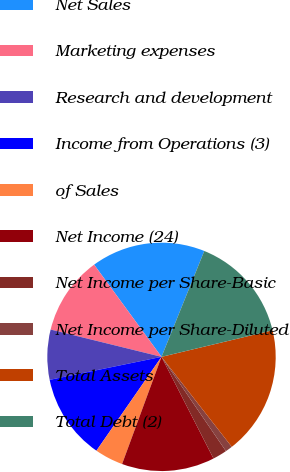Convert chart. <chart><loc_0><loc_0><loc_500><loc_500><pie_chart><fcel>Net Sales<fcel>Marketing expenses<fcel>Research and development<fcel>Income from Operations (3)<fcel>of Sales<fcel>Net Income (24)<fcel>Net Income per Share-Basic<fcel>Net Income per Share-Diluted<fcel>Total Assets<fcel>Total Debt (2)<nl><fcel>16.16%<fcel>11.11%<fcel>7.07%<fcel>12.12%<fcel>4.04%<fcel>13.13%<fcel>2.02%<fcel>1.01%<fcel>18.18%<fcel>15.15%<nl></chart> 